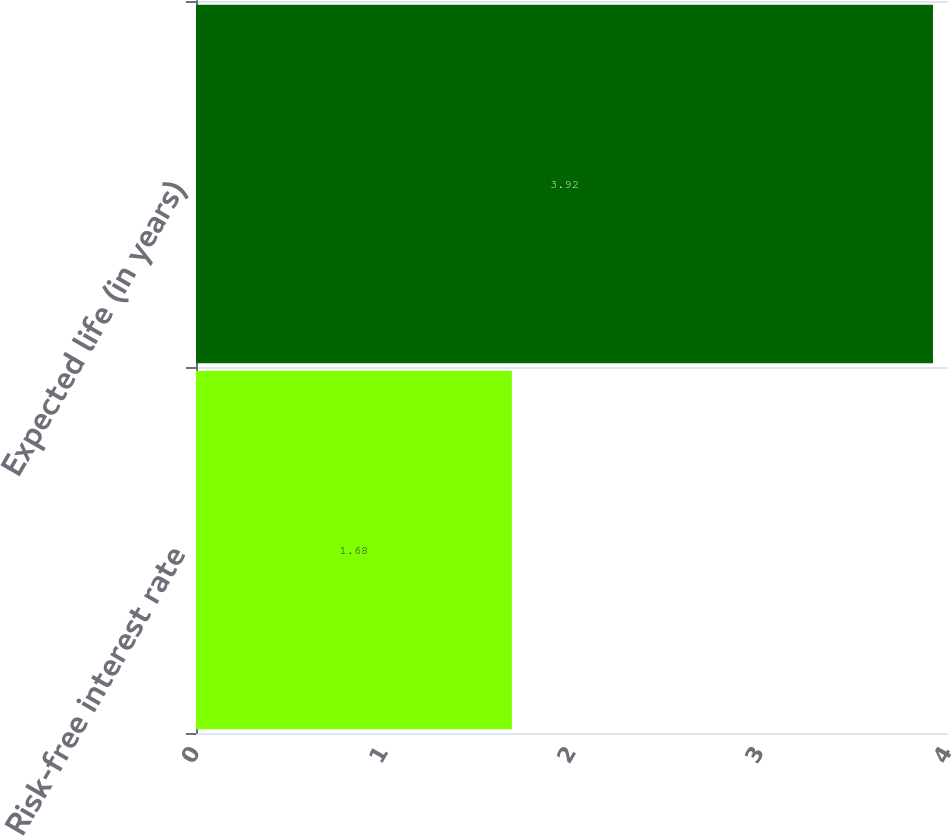<chart> <loc_0><loc_0><loc_500><loc_500><bar_chart><fcel>Risk-free interest rate<fcel>Expected life (in years)<nl><fcel>1.68<fcel>3.92<nl></chart> 